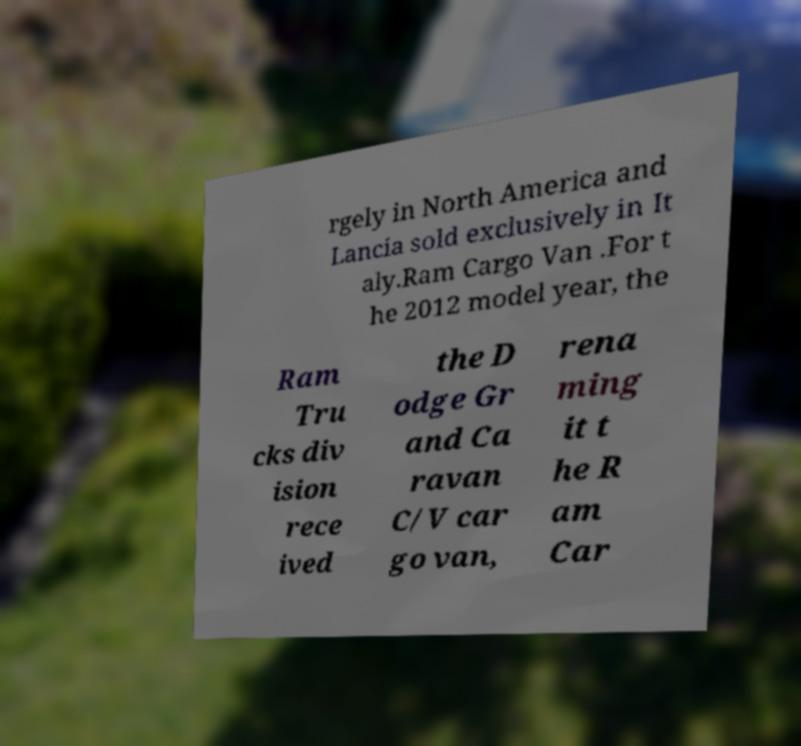Please read and relay the text visible in this image. What does it say? rgely in North America and Lancia sold exclusively in It aly.Ram Cargo Van .For t he 2012 model year, the Ram Tru cks div ision rece ived the D odge Gr and Ca ravan C/V car go van, rena ming it t he R am Car 